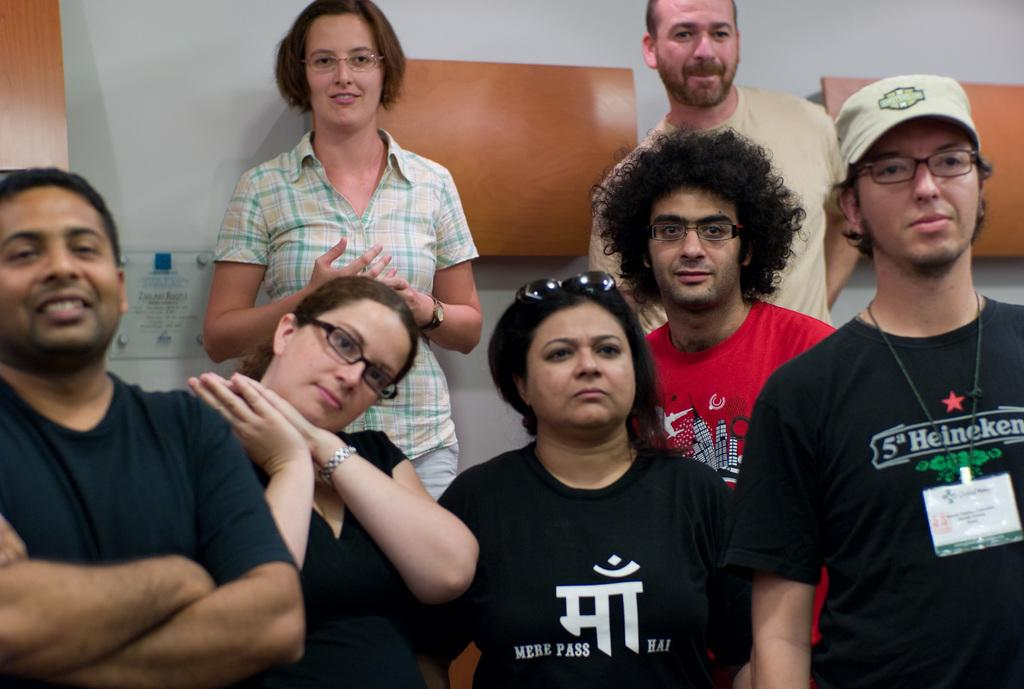Who or what can be seen in the image? There are people in the image. What type of structure is visible in the image? There is a wall visible in the image. What material is used for the boards in the image? The boards in the image are made of wood. How many pumps can be seen in the image? There are no pumps present in the image. What type of card is being used by the people in the image? There is no card visible in the image. 